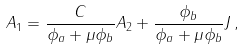<formula> <loc_0><loc_0><loc_500><loc_500>A _ { 1 } = \frac { C } { \phi _ { a } + \mu \phi _ { b } } A _ { 2 } + \frac { \phi _ { b } } { \phi _ { a } + \mu \phi _ { b } } J \, ,</formula> 